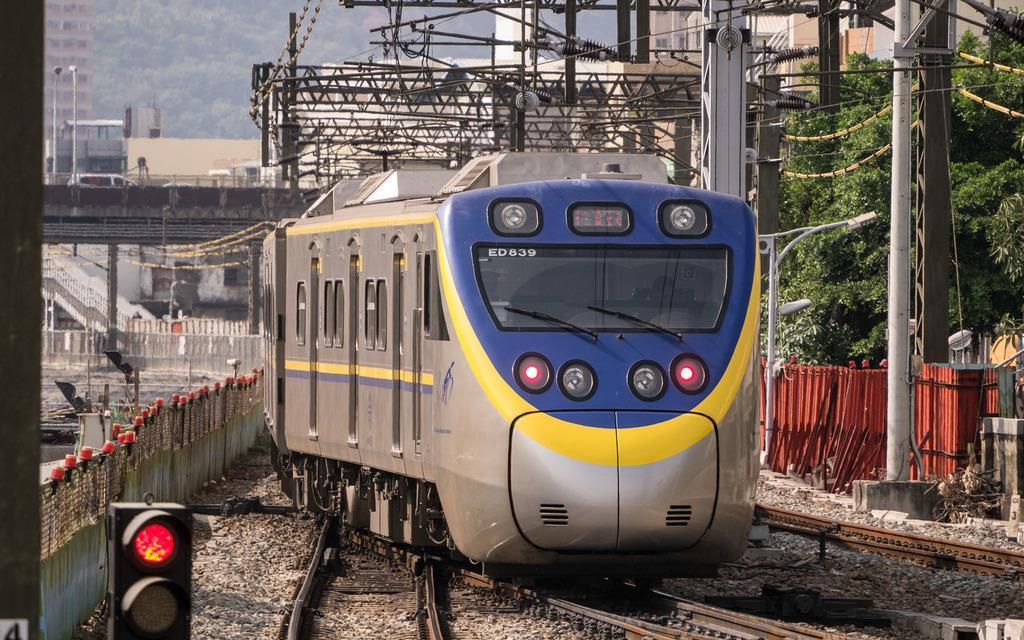How would you summarize this image in a sentence or two? In this image in the front there is a train running on the railway track. In the background there are trees, there are poles, there is a bridge, on the bridge there is a car moving and there is a staircase, there is a fence and there is a building. In the front on the left side there is a signal. 